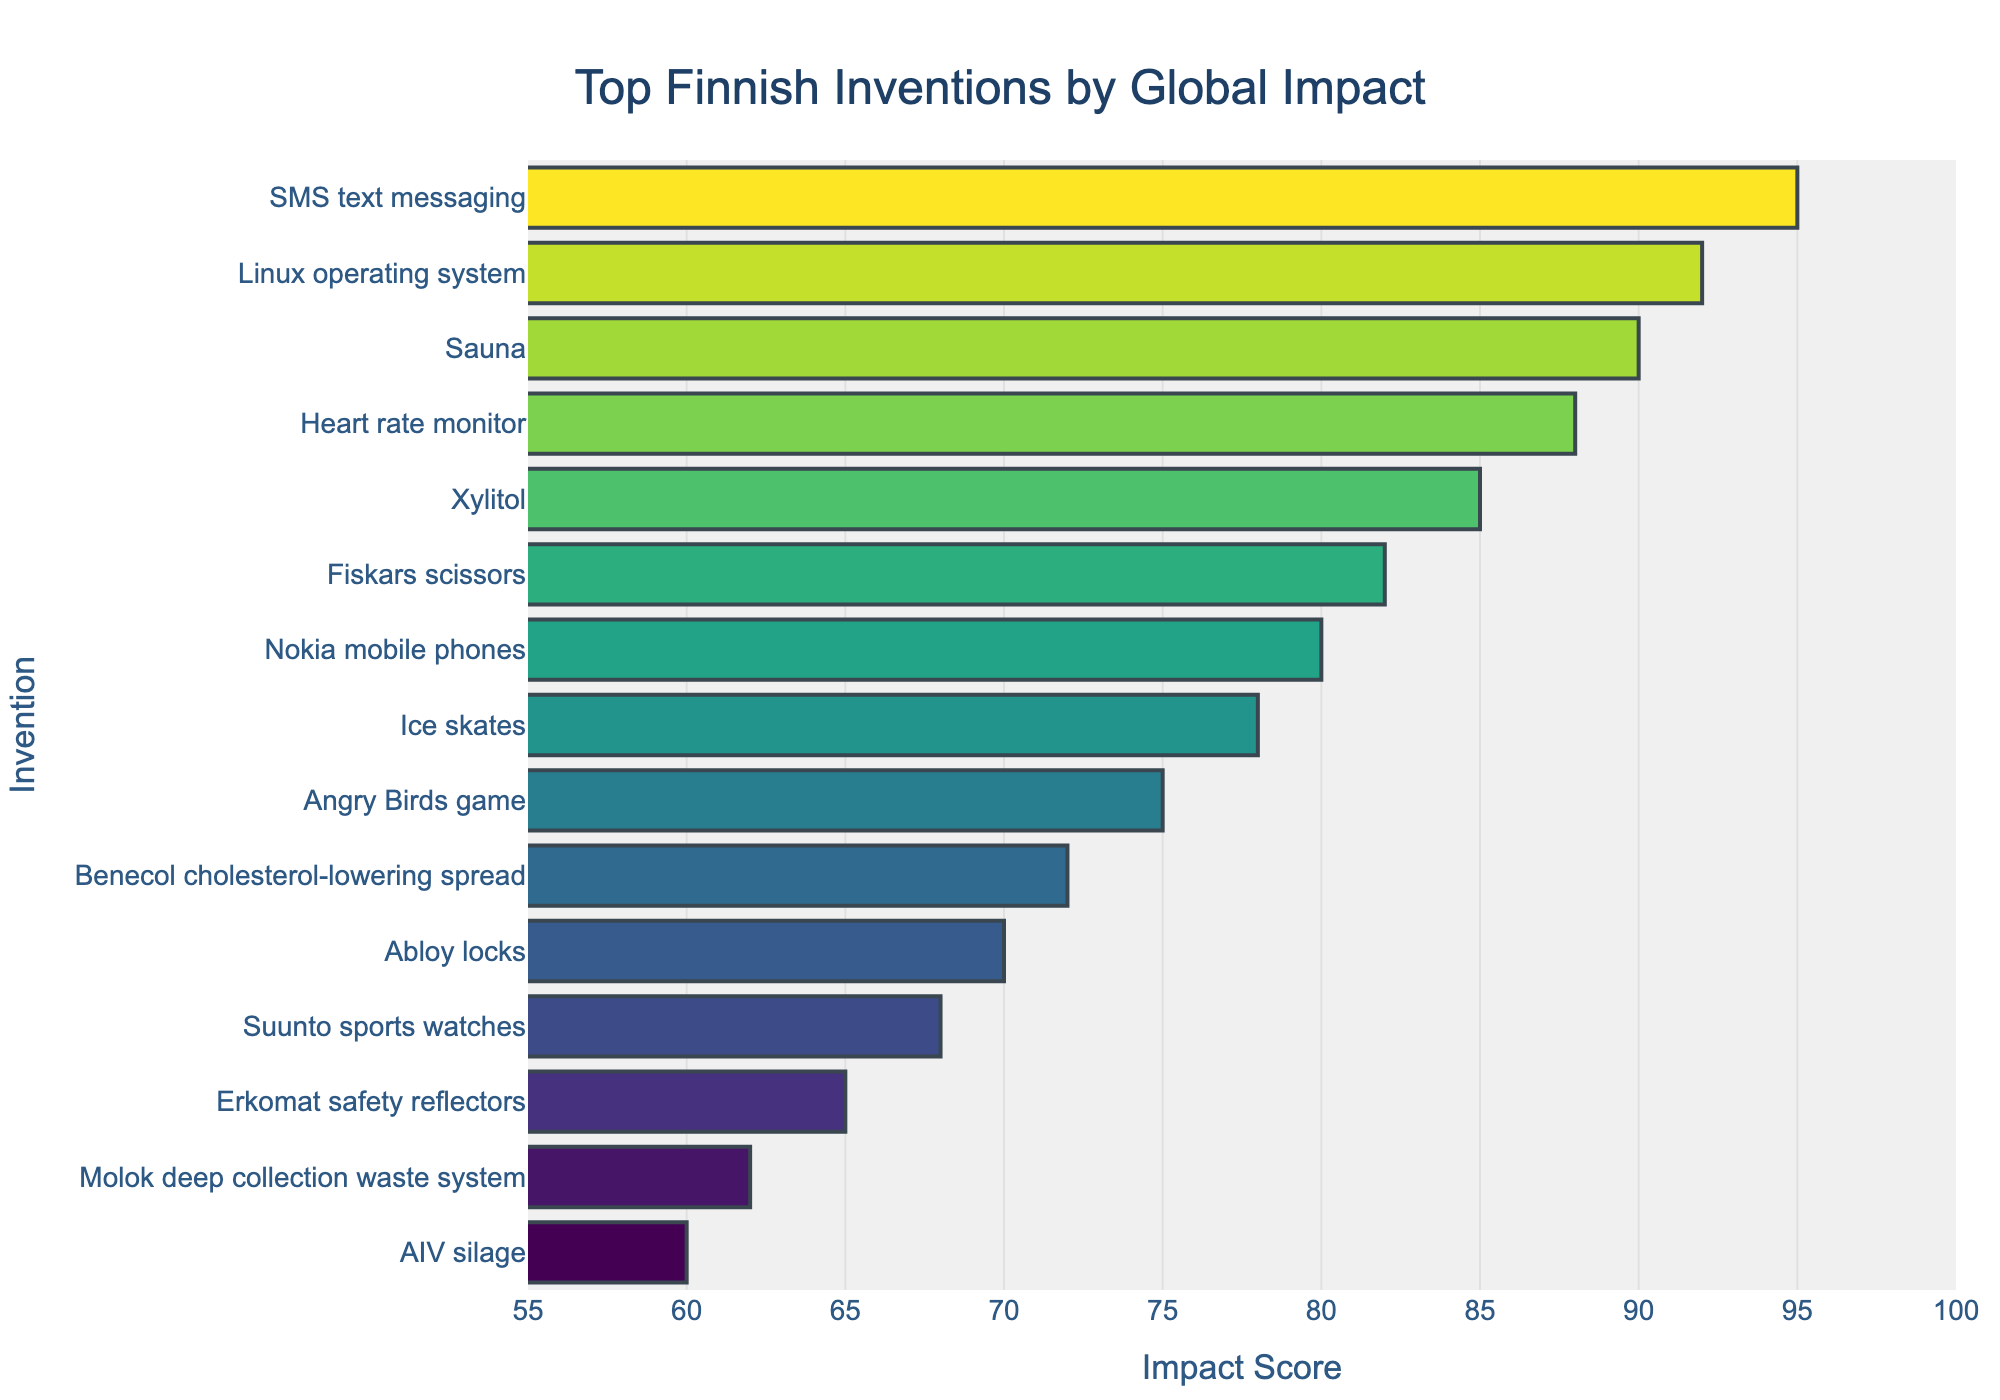What's the invention with the highest impact score? The highest bar corresponds to "SMS text messaging" with an impact score of 95.
Answer: SMS text messaging Which invention has a lower impact score, Sauna or Nokia mobile phones? The bar for Sauna has an impact score of 90, while Nokia mobile phones has 80. Therefore, Nokia mobile phones has a lower impact score.
Answer: Nokia mobile phones What is the total impact score of Sauna, Xylitol, and Fiskars scissors? The impact scores are Sauna (90), Xylitol (85), and Fiskars scissors (82). Adding these together gives 90 + 85 + 82 = 257.
Answer: 257 Which inventions have an impact score above 90? The bars with impact scores above 90 are SMS text messaging (95) and Linux operating system (92).
Answer: SMS text messaging, Linux operating system What's the difference in impact score between Suunto sports watches and Erkomat safety reflectors? The impact score of Suunto sports watches is 68, and Erkomat safety reflectors is 65. The difference is 68 - 65 = 3.
Answer: 3 What is the average impact score of the bottom 3 inventions by global impact? The bottom 3 inventions by impact score are Molok deep collection waste system (62), AIV silage (60), and Erkomat safety reflectors (65). The average is (62 + 60 + 65)/3 = 62.33.
Answer: 62.33 Which invention ranks higher, Ice skates or Angry Birds game, based on impact score? The impact score for Ice skates is 78 and for Angry Birds game is 75. Ice skates have a higher impact score.
Answer: Ice skates Which inventions share a color gradient closer to green? Inventions with bars more towards the higher end of the color gradient are SMS text messaging, Linux operating system, and Sauna, as they have the highest impact scores.
Answer: SMS text messaging, Linux operating system, Sauna What is the combined impact score of the inventions in the bottom half of the chart? The bottom half includes Impact Scores for Erkomat safety reflectors (65), Suunto sports watches (68), Abloy locks (70), Benecol spread (72), Angry Birds game (75), Ice skates (78), and Nokia mobile phones (80). Summing these gives 65 + 68 + 70 + 72 + 75 + 78 + 80 = 508.
Answer: 508 Compare the impact of the invention with the lowest visual mark on the bar chart to the one with the highest. The lowest visual mark corresponds to AIV silage with an impact score of 60. The highest is SMS text messaging, with an impact score of 95. The difference is 95 - 60 = 35.
Answer: 35 